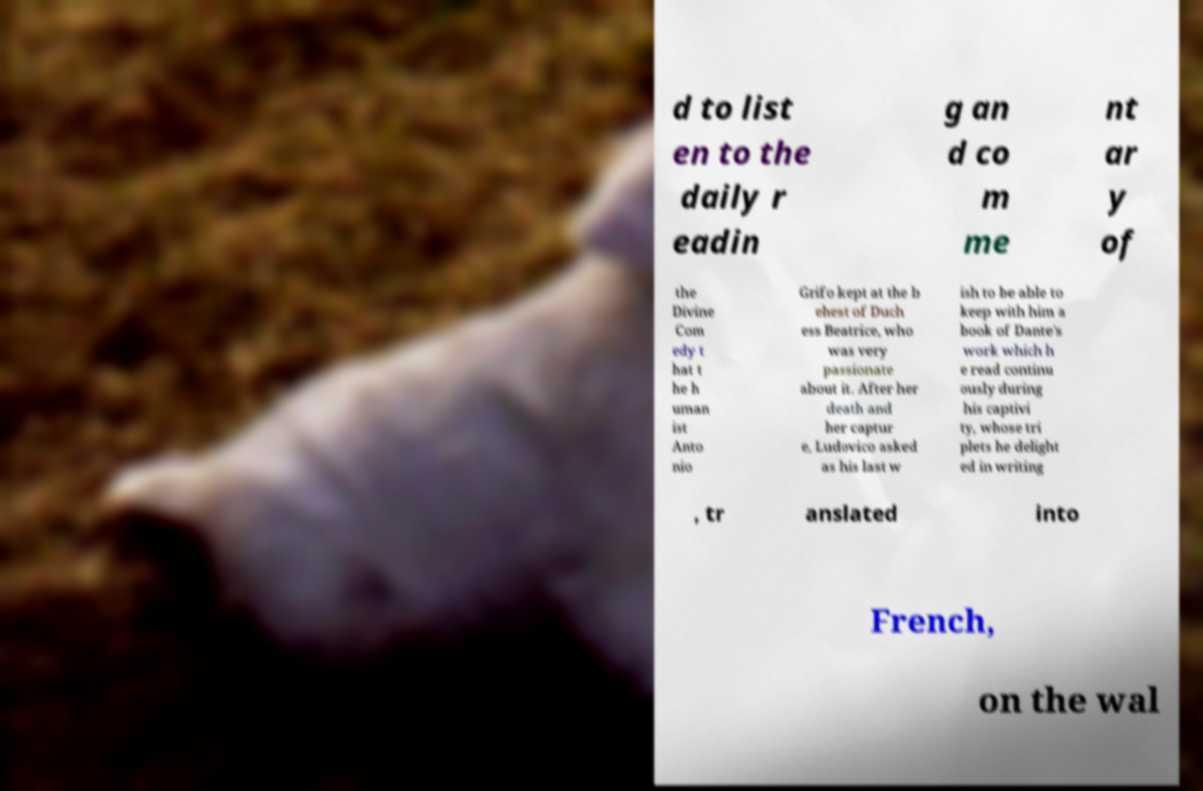I need the written content from this picture converted into text. Can you do that? d to list en to the daily r eadin g an d co m me nt ar y of the Divine Com edy t hat t he h uman ist Anto nio Grifo kept at the b ehest of Duch ess Beatrice, who was very passionate about it. After her death and her captur e, Ludovico asked as his last w ish to be able to keep with him a book of Dante's work which h e read continu ously during his captivi ty, whose tri plets he delight ed in writing , tr anslated into French, on the wal 